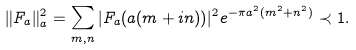<formula> <loc_0><loc_0><loc_500><loc_500>\| F _ { a } \| ^ { 2 } _ { a } = \sum _ { m , n } | F _ { a } ( a ( m + i n ) ) | ^ { 2 } e ^ { - \pi a ^ { 2 } ( m ^ { 2 } + n ^ { 2 } ) } \prec 1 .</formula> 